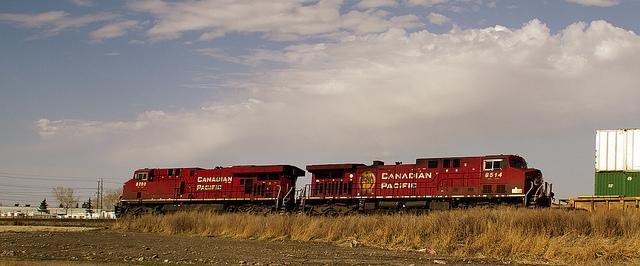How many trains can you see?
Give a very brief answer. 1. How many brown horses are there?
Give a very brief answer. 0. 